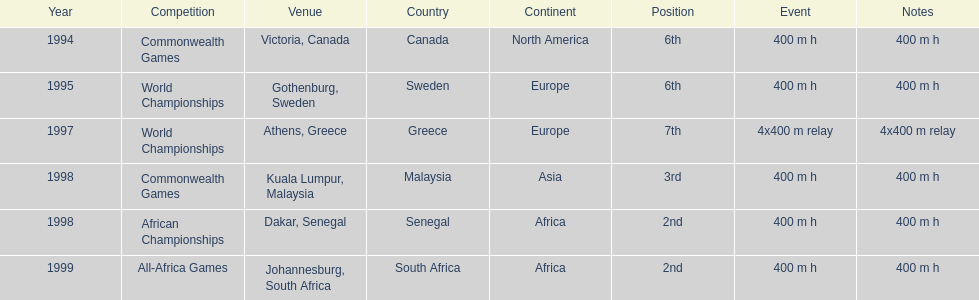What was the venue before dakar, senegal? Kuala Lumpur, Malaysia. 